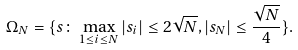Convert formula to latex. <formula><loc_0><loc_0><loc_500><loc_500>\Omega _ { N } = \{ s \colon \max _ { 1 \leq i \leq N } | s _ { i } | \leq 2 \sqrt { N } , | s _ { N } | \leq \frac { \sqrt { N } } { 4 } \} .</formula> 